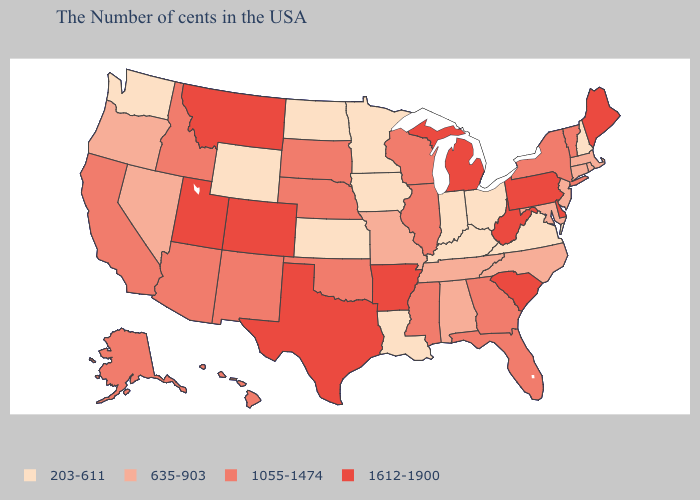What is the lowest value in states that border Missouri?
Keep it brief. 203-611. Does Idaho have the highest value in the USA?
Keep it brief. No. Is the legend a continuous bar?
Be succinct. No. Is the legend a continuous bar?
Quick response, please. No. What is the value of Michigan?
Keep it brief. 1612-1900. What is the highest value in the Northeast ?
Write a very short answer. 1612-1900. Name the states that have a value in the range 1612-1900?
Keep it brief. Maine, Delaware, Pennsylvania, South Carolina, West Virginia, Michigan, Arkansas, Texas, Colorado, Utah, Montana. What is the lowest value in states that border Utah?
Quick response, please. 203-611. Among the states that border Tennessee , does Arkansas have the highest value?
Concise answer only. Yes. Among the states that border New Mexico , which have the highest value?
Give a very brief answer. Texas, Colorado, Utah. What is the value of New York?
Be succinct. 1055-1474. What is the highest value in states that border California?
Write a very short answer. 1055-1474. Name the states that have a value in the range 1612-1900?
Answer briefly. Maine, Delaware, Pennsylvania, South Carolina, West Virginia, Michigan, Arkansas, Texas, Colorado, Utah, Montana. What is the value of Nevada?
Short answer required. 635-903. Does California have a higher value than Ohio?
Concise answer only. Yes. 